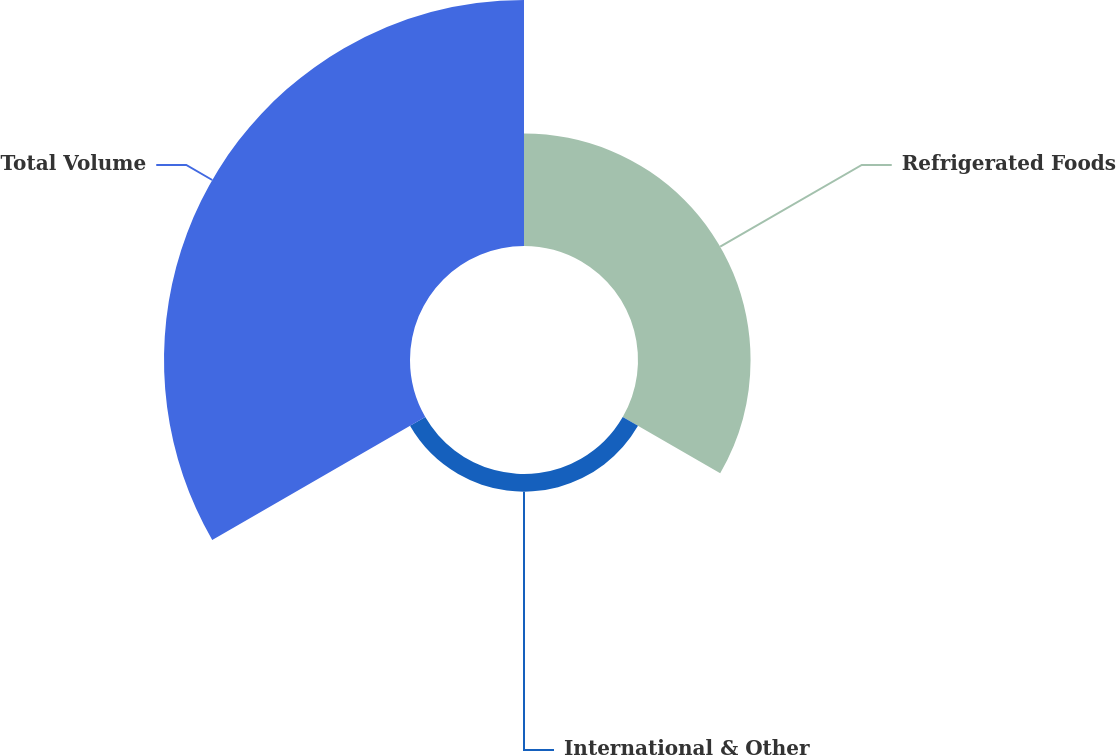Convert chart to OTSL. <chart><loc_0><loc_0><loc_500><loc_500><pie_chart><fcel>Refrigerated Foods<fcel>International & Other<fcel>Total Volume<nl><fcel>29.92%<fcel>4.69%<fcel>65.39%<nl></chart> 